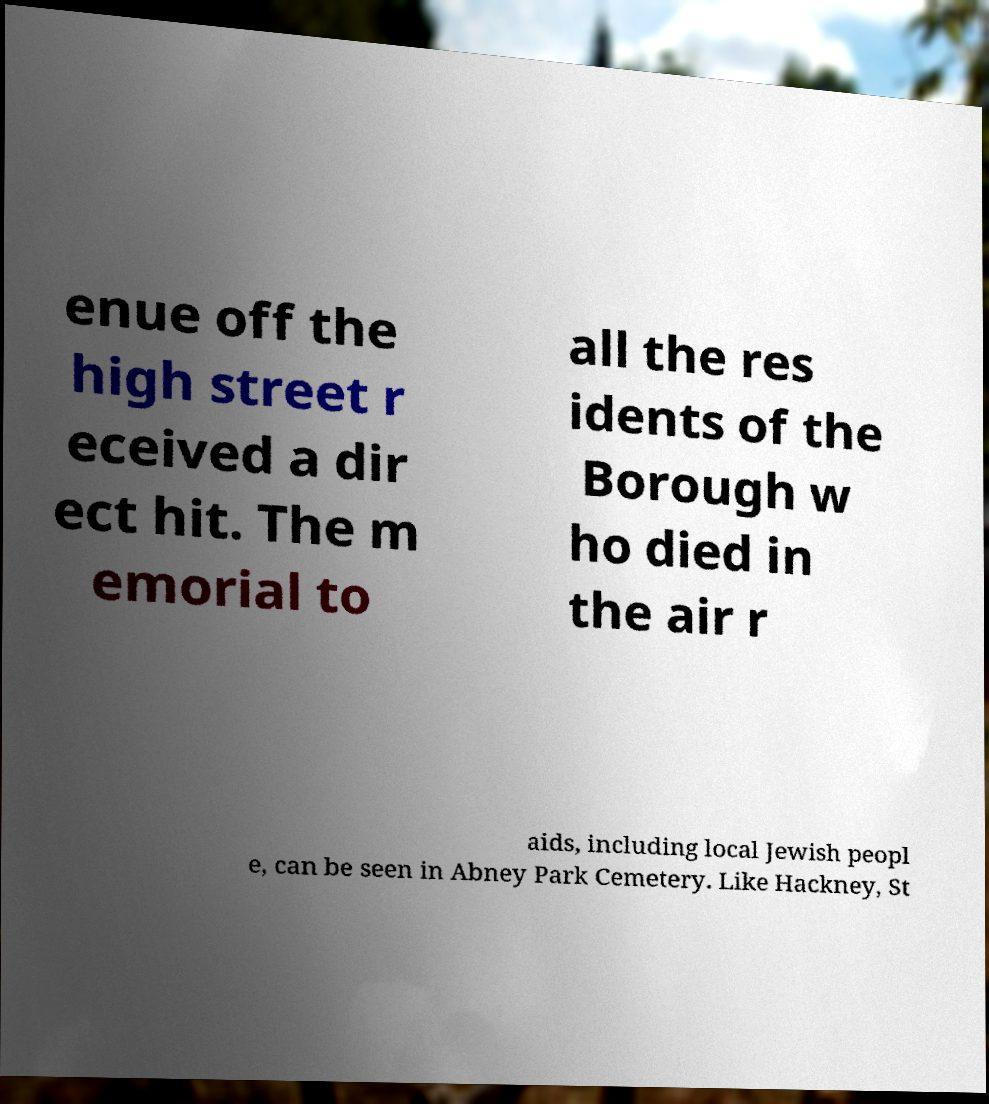Could you extract and type out the text from this image? enue off the high street r eceived a dir ect hit. The m emorial to all the res idents of the Borough w ho died in the air r aids, including local Jewish peopl e, can be seen in Abney Park Cemetery. Like Hackney, St 